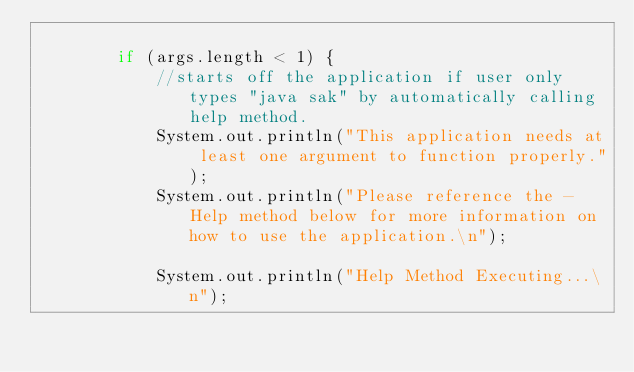Convert code to text. <code><loc_0><loc_0><loc_500><loc_500><_Java_>
        if (args.length < 1) {
            //starts off the application if user only types "java sak" by automatically calling help method.
            System.out.println("This application needs at least one argument to function properly.");
            System.out.println("Please reference the -Help method below for more information on how to use the application.\n");

            System.out.println("Help Method Executing...\n");
            </code> 